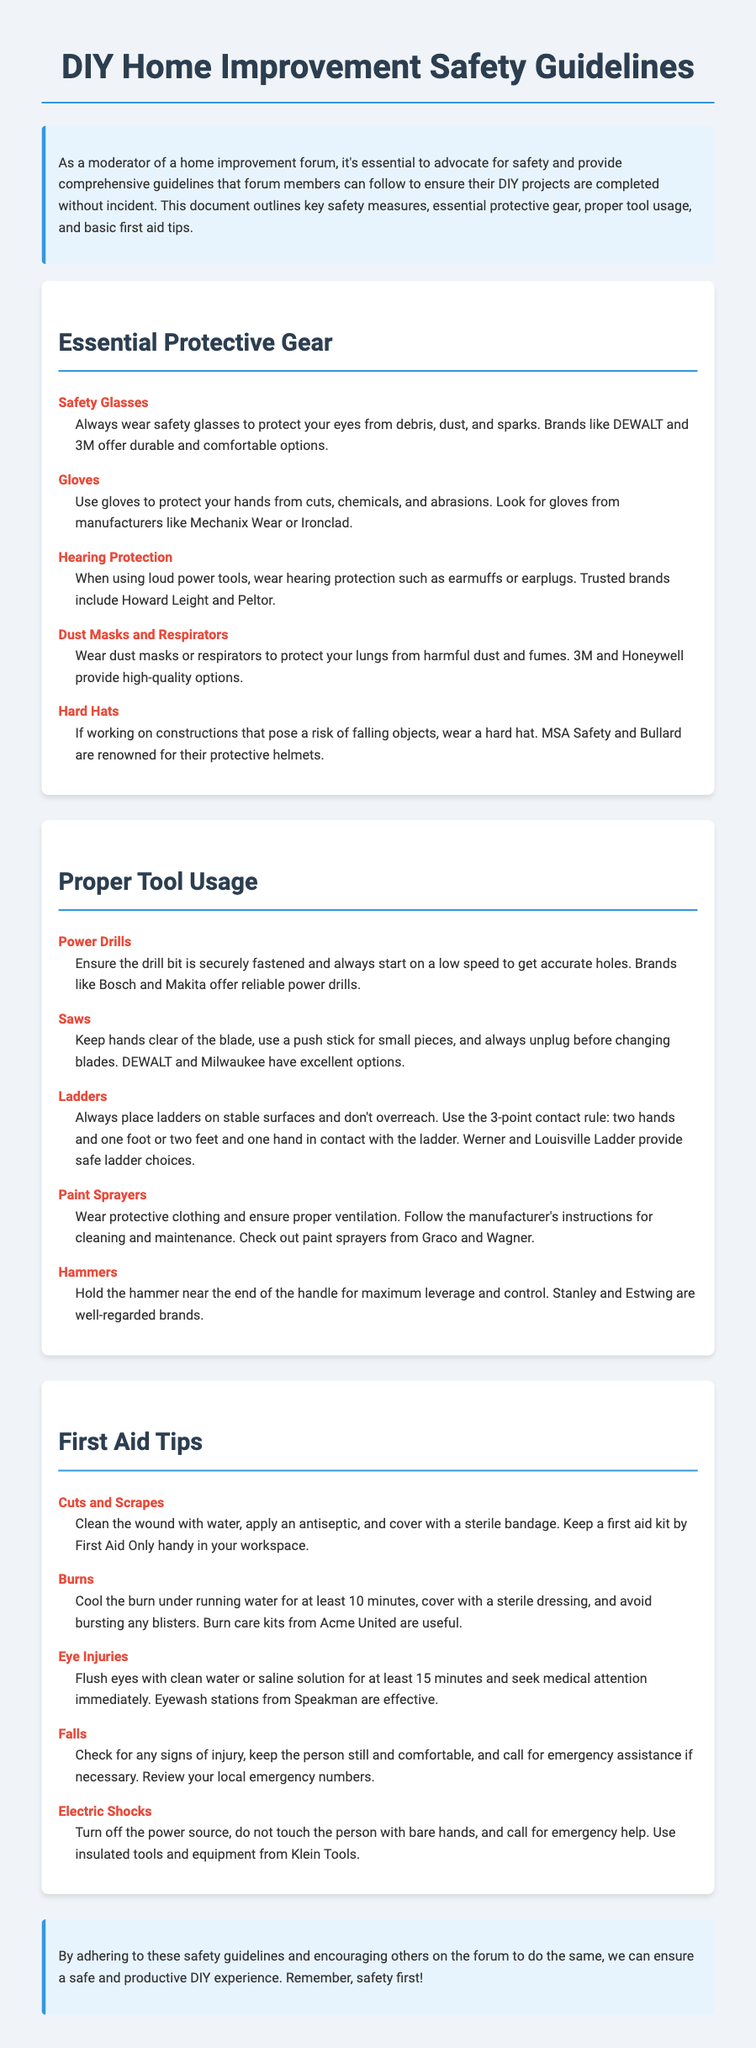What should you wear to protect your eyes? The guideline suggests wearing safety glasses to protect your eyes from debris, dust, and sparks.
Answer: Safety glasses Which brand is recommended for gloves? Mechanix Wear or Ironclad are suggested for gloves to protect your hands.
Answer: Mechanix Wear or Ironclad What is the three-point contact rule related to? The three-point contact rule pertains to ladder usage, keeping two hands and one foot or two feet and one hand in contact with the ladder.
Answer: Ladder usage How long should you cool a burn with running water? The guideline recommends cooling a burn under running water for at least 10 minutes.
Answer: At least 10 minutes What type of injury requires flushing eyes with water? Eye injuries necessitate flushing eyes with clean water or saline solution for at least 15 minutes.
Answer: Eye injuries Which tool requires ensuring the drill bit is securely fastened? Power drills require ensuring the drill bit is securely fastened before use.
Answer: Power drills What should be used to clean a wound? The document suggests using water to clean a wound before applying antiseptic.
Answer: Water Name one protective gear for hearing. Hearing protection such as earmuffs or earplugs should be worn.
Answer: Earmuffs or earplugs Which brand is suggested for power drills? Bosch and Makita are recommended as reliable brands for power drills.
Answer: Bosch and Makita 